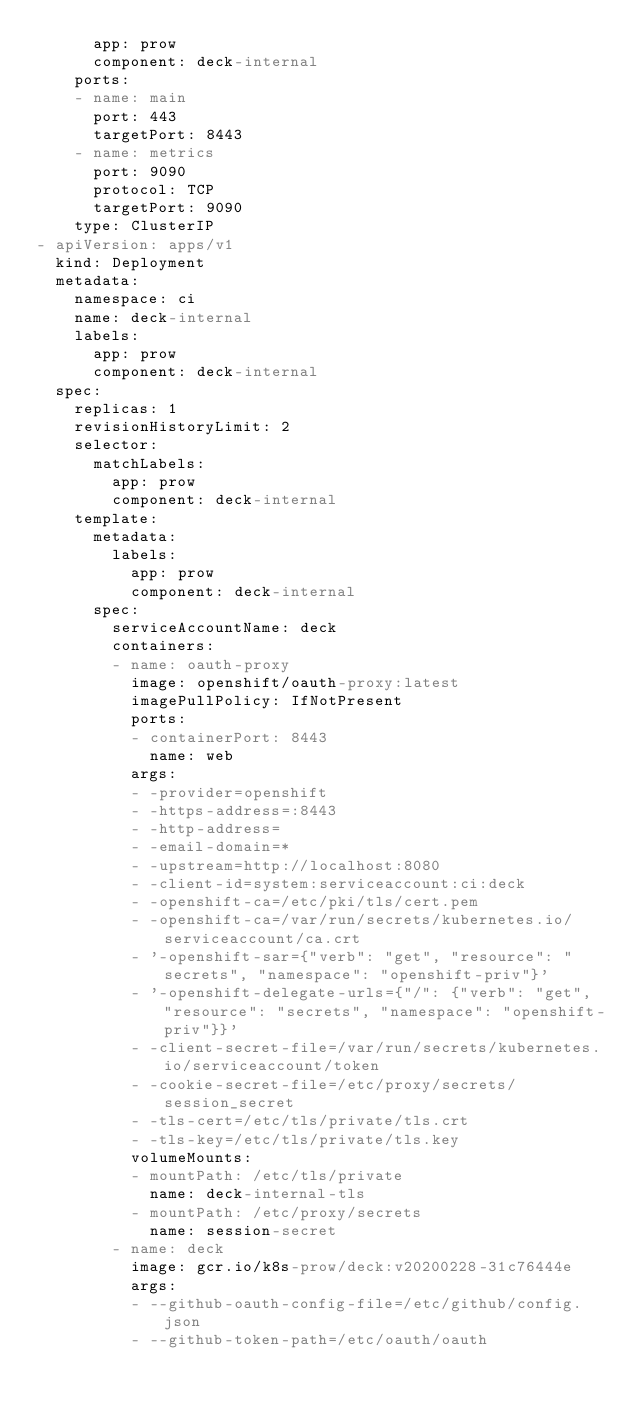<code> <loc_0><loc_0><loc_500><loc_500><_YAML_>      app: prow
      component: deck-internal
    ports:
    - name: main
      port: 443
      targetPort: 8443
    - name: metrics
      port: 9090
      protocol: TCP
      targetPort: 9090
    type: ClusterIP
- apiVersion: apps/v1
  kind: Deployment
  metadata:
    namespace: ci
    name: deck-internal
    labels:
      app: prow
      component: deck-internal
  spec:
    replicas: 1
    revisionHistoryLimit: 2
    selector:
      matchLabels:
        app: prow
        component: deck-internal
    template:
      metadata:
        labels:
          app: prow
          component: deck-internal
      spec:
        serviceAccountName: deck
        containers:
        - name: oauth-proxy
          image: openshift/oauth-proxy:latest
          imagePullPolicy: IfNotPresent
          ports:
          - containerPort: 8443
            name: web
          args:
          - -provider=openshift
          - -https-address=:8443
          - -http-address=
          - -email-domain=*
          - -upstream=http://localhost:8080
          - -client-id=system:serviceaccount:ci:deck
          - -openshift-ca=/etc/pki/tls/cert.pem
          - -openshift-ca=/var/run/secrets/kubernetes.io/serviceaccount/ca.crt
          - '-openshift-sar={"verb": "get", "resource": "secrets", "namespace": "openshift-priv"}'
          - '-openshift-delegate-urls={"/": {"verb": "get", "resource": "secrets", "namespace": "openshift-priv"}}'
          - -client-secret-file=/var/run/secrets/kubernetes.io/serviceaccount/token
          - -cookie-secret-file=/etc/proxy/secrets/session_secret
          - -tls-cert=/etc/tls/private/tls.crt
          - -tls-key=/etc/tls/private/tls.key
          volumeMounts:
          - mountPath: /etc/tls/private
            name: deck-internal-tls
          - mountPath: /etc/proxy/secrets
            name: session-secret
        - name: deck
          image: gcr.io/k8s-prow/deck:v20200228-31c76444e
          args:
          - --github-oauth-config-file=/etc/github/config.json
          - --github-token-path=/etc/oauth/oauth</code> 